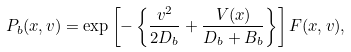<formula> <loc_0><loc_0><loc_500><loc_500>P _ { b } ( x , v ) = \exp \left [ - \left \{ \frac { v ^ { 2 } } { 2 D _ { b } } + \frac { V ( x ) } { D _ { b } + B _ { b } } \right \} \right ] F ( x , v ) ,</formula> 